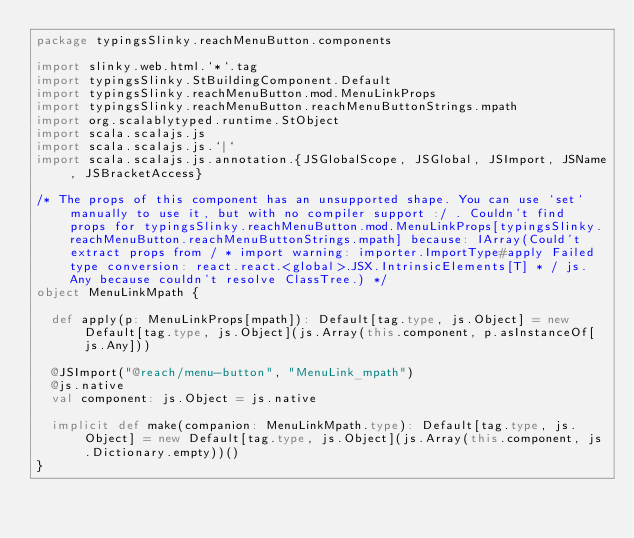<code> <loc_0><loc_0><loc_500><loc_500><_Scala_>package typingsSlinky.reachMenuButton.components

import slinky.web.html.`*`.tag
import typingsSlinky.StBuildingComponent.Default
import typingsSlinky.reachMenuButton.mod.MenuLinkProps
import typingsSlinky.reachMenuButton.reachMenuButtonStrings.mpath
import org.scalablytyped.runtime.StObject
import scala.scalajs.js
import scala.scalajs.js.`|`
import scala.scalajs.js.annotation.{JSGlobalScope, JSGlobal, JSImport, JSName, JSBracketAccess}

/* The props of this component has an unsupported shape. You can use `set` manually to use it, but with no compiler support :/ . Couldn't find props for typingsSlinky.reachMenuButton.mod.MenuLinkProps[typingsSlinky.reachMenuButton.reachMenuButtonStrings.mpath] because: IArray(Could't extract props from / * import warning: importer.ImportType#apply Failed type conversion: react.react.<global>.JSX.IntrinsicElements[T] * / js.Any because couldn't resolve ClassTree.) */
object MenuLinkMpath {
  
  def apply(p: MenuLinkProps[mpath]): Default[tag.type, js.Object] = new Default[tag.type, js.Object](js.Array(this.component, p.asInstanceOf[js.Any]))
  
  @JSImport("@reach/menu-button", "MenuLink_mpath")
  @js.native
  val component: js.Object = js.native
  
  implicit def make(companion: MenuLinkMpath.type): Default[tag.type, js.Object] = new Default[tag.type, js.Object](js.Array(this.component, js.Dictionary.empty))()
}
</code> 